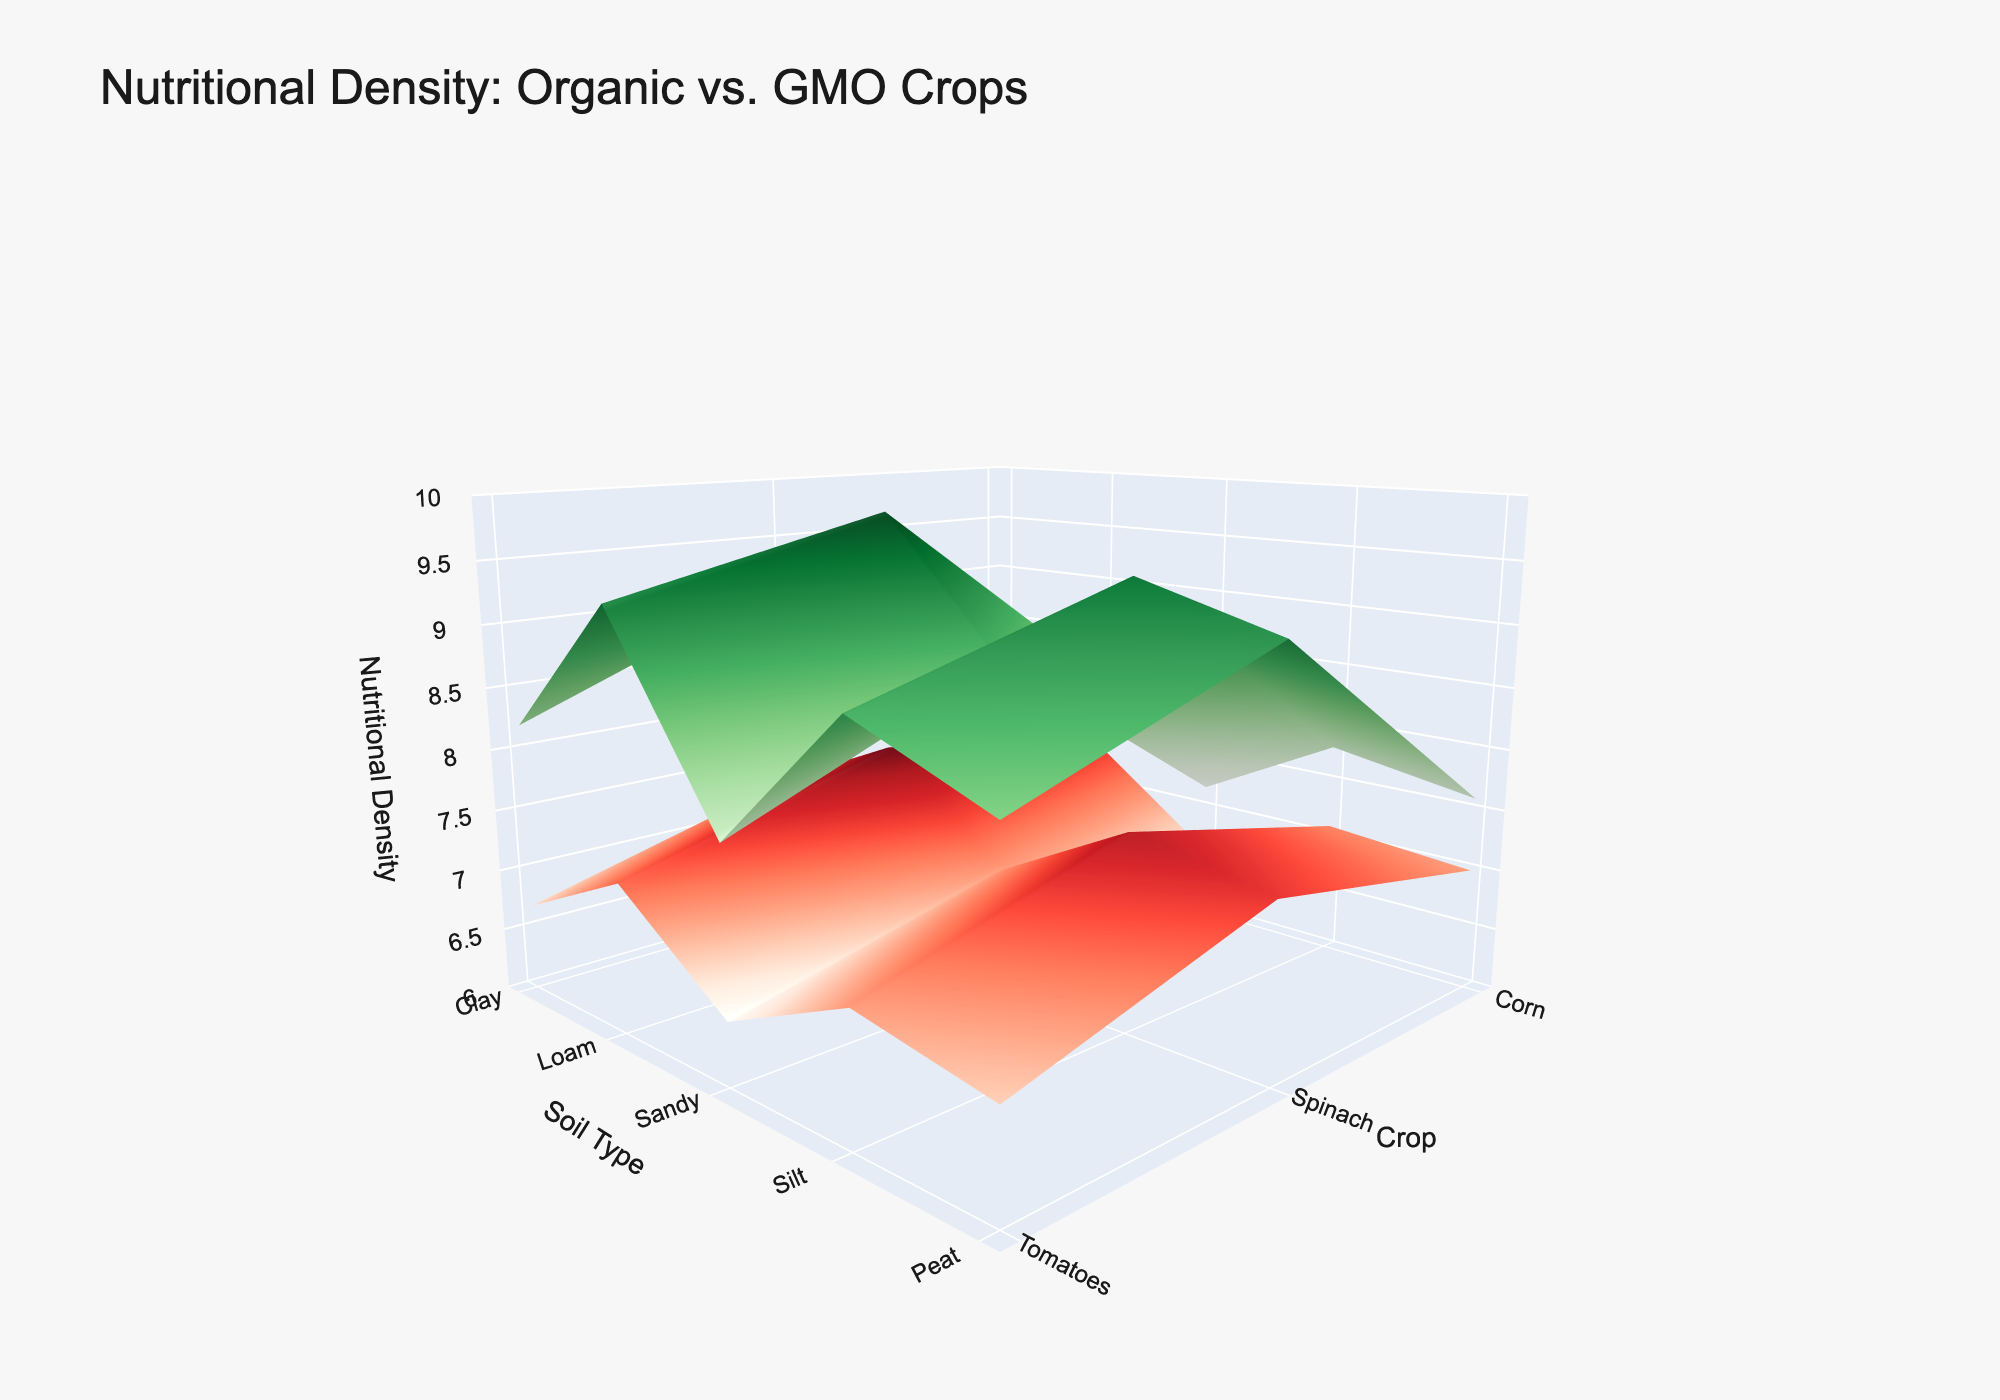What's the title of the figure? Look at the top of the plot for the title text.
Answer: Nutritional Density: Organic vs. GMO Crops How many types of soil are represented in the figure? Count the distinct tick marks on the x-axis.
Answer: 5 Which type of crop has the highest nutritional density in organic farming on loam soil? Find the loam soil section on the x-axis, then look for the highest peak in the 'Organic' surface in the y direction corresponding to the crops.
Answer: Spinach What's the difference in nutritional density between organic and GMO tomatoes on silt soil? Locate 'Silt' on the x-axis and 'Tomatoes' on the y-axis, then note the height difference between the red (GMO) and green (Organic) surfaces.
Answer: 1.9 Which crop shows the least variation between organic and GMO nutritional density across all soil types? Compare the height differences between the red and green surfaces for all crops across all soil types and find the smallest difference.
Answer: Corn On which type of soil does organic spinach show the highest nutritional density? Look for the highest peak on the green surface within the 'Spinach' section on the y-axis.
Answer: Loam What's the average nutritional density of organic corn across all soil types? Find the values of organic corn in each soil type (from green surface), sum them, and then divide by the number of soil types (5).
Answer: 7.64 In which soil type is the difference in nutritional density between organic and GMO crops the greatest? Look for the largest gap between the red and green surfaces across soil types.
Answer: Loam How does the nutritional density of organic crops compare to GMO crops on sandy soil? Compare the overall height of green (organic) surfaces to red (GMO) surfaces in the sandy section.
Answer: Organic is higher than GMO Which crop and soil combination shows the highest overall nutritional density? Identify the highest peak in the entire plot and determine the corresponding crop and soil type using x and y axes.
Answer: Organic Spinach on Loam 